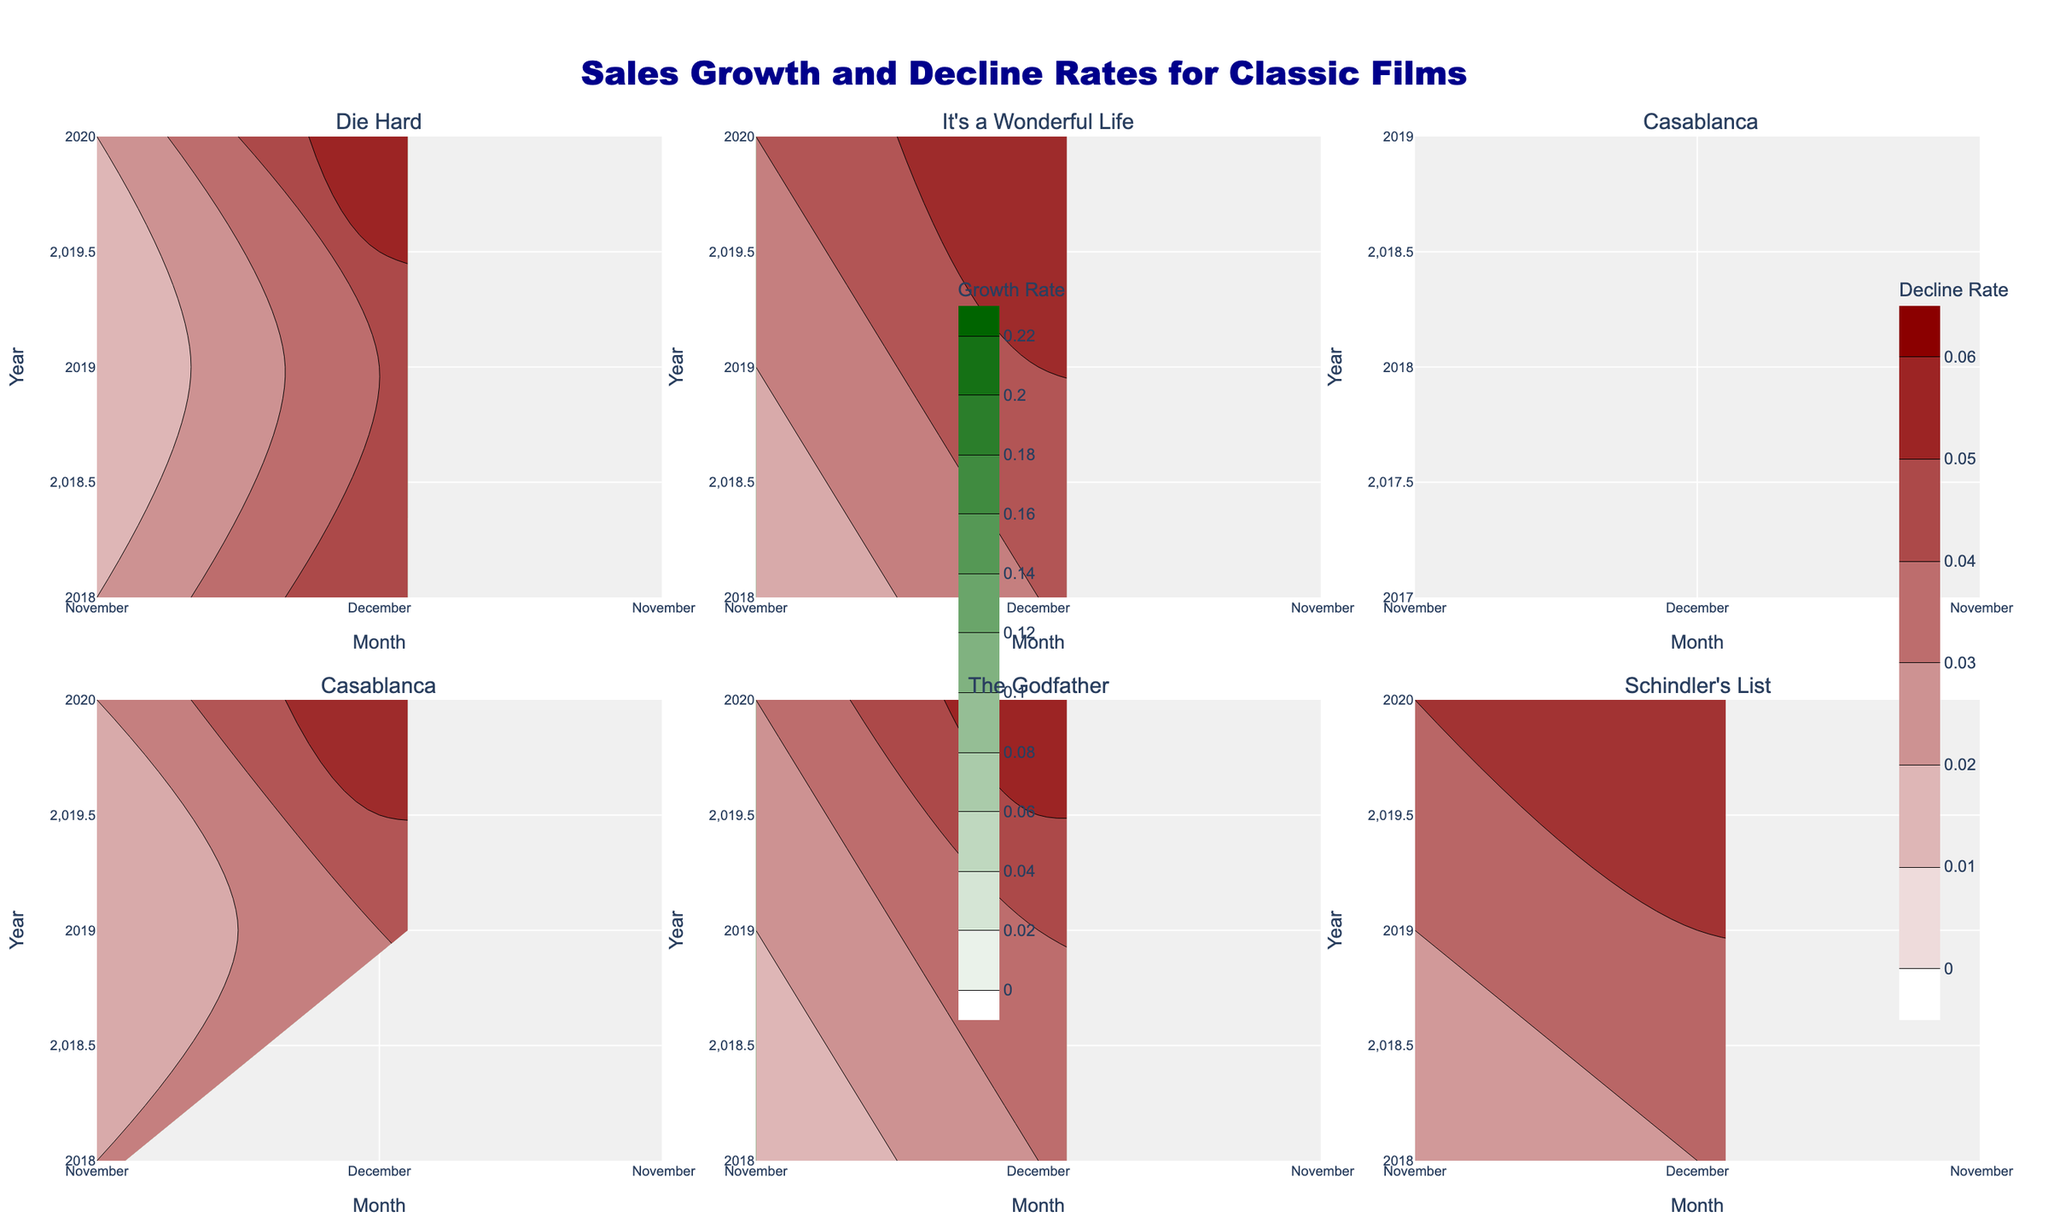What's the title of the overall figure? The title is typically found at the top of the figure. In this case, it is "Sales Growth and Decline Rates for Classic Films".
Answer: Sales Growth and Decline Rates for Classic Films How many subplots are there in the figure? The figure creates subplots for each film title. Since there are six unique film titles in the dataset, there are six subplots.
Answer: 6 Which film shows the highest sales growth rate in December 2019? To answer this, look at the December 2019 data points for the sales growth rate across all subplots. The subplot of 'The Godfather' shows the highest growth rate of 0.22.
Answer: The Godfather Between 2018 and 2020, does "Casablanca" show a higher growth rate in November or December? Compare the growth rate for "Casablanca" in the two months over the years. In November, it remains between 0.08 and 0.10, whereas in December, it goes up to 0.16 in 2020. Thus, December has a higher rate.
Answer: December In 2020, which month had the higher sales decline rate for "Die Hard"? Look at the contour values for 'Die Hard' in 2020 for both November and December in terms of decline rate. November shows a higher decline rate at 0.06 compared to December's 0.02.
Answer: November Which film has the least variance in sales growth rate between 2018 and 2020? To find this, observe the contour plots and note the spread of growth rates. "Schindler's List" shows the least variance as it ranges closely between 0.07 and 0.10.
Answer: Schindler's List How does the decline rate in November 2019 compare to November 2020 for "The Godfather"? Examine the decline rates in November 2019 and 2020 for "The Godfather". The rate increases from 0.04 in 2019 to 0.06 in 2020, meaning it shows an upward trend.
Answer: It increased For "It's a Wonderful Life," is the growth rate more consistent in November or December between 2018 and 2020? "It's a Wonderful Life" shows growth rates making a noticeable change in November (0.10 in 2018, 0.11 in 2019, 0.12 in 2020), while in December, it's 0.13 fairly consistently in 2018 and 2020 and 0.14 in 2019. Therefore, December is more consistent.
Answer: December 